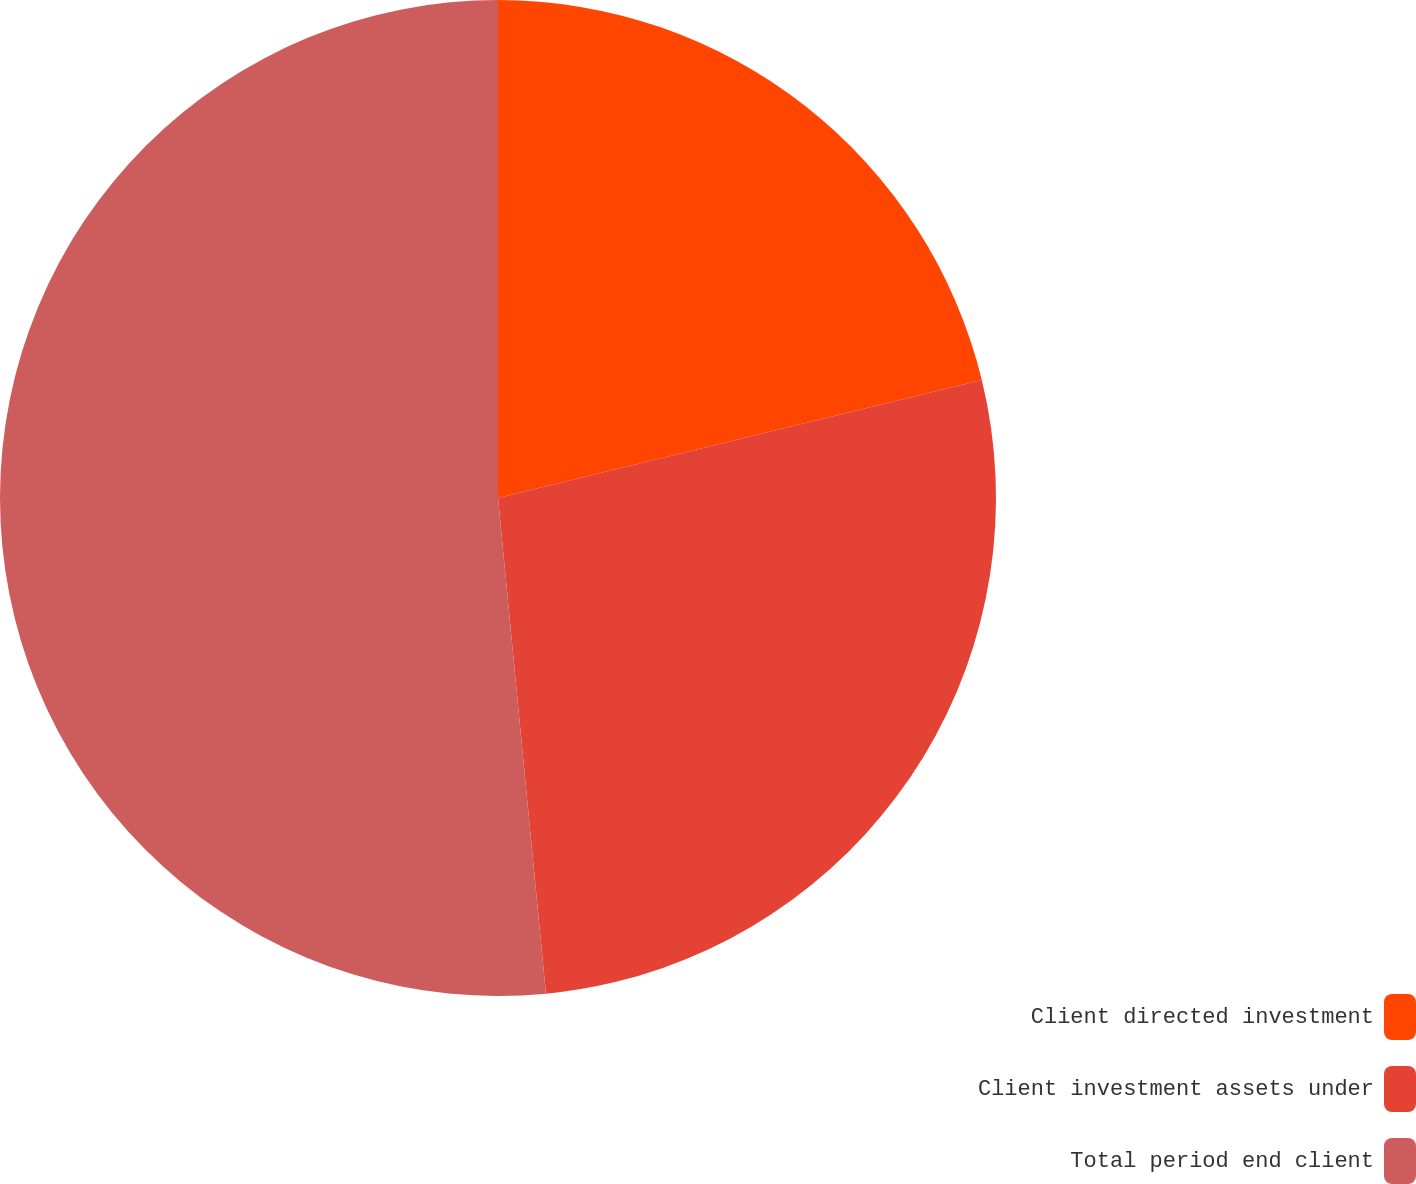<chart> <loc_0><loc_0><loc_500><loc_500><pie_chart><fcel>Client directed investment<fcel>Client investment assets under<fcel>Total period end client<nl><fcel>21.19%<fcel>27.27%<fcel>51.53%<nl></chart> 